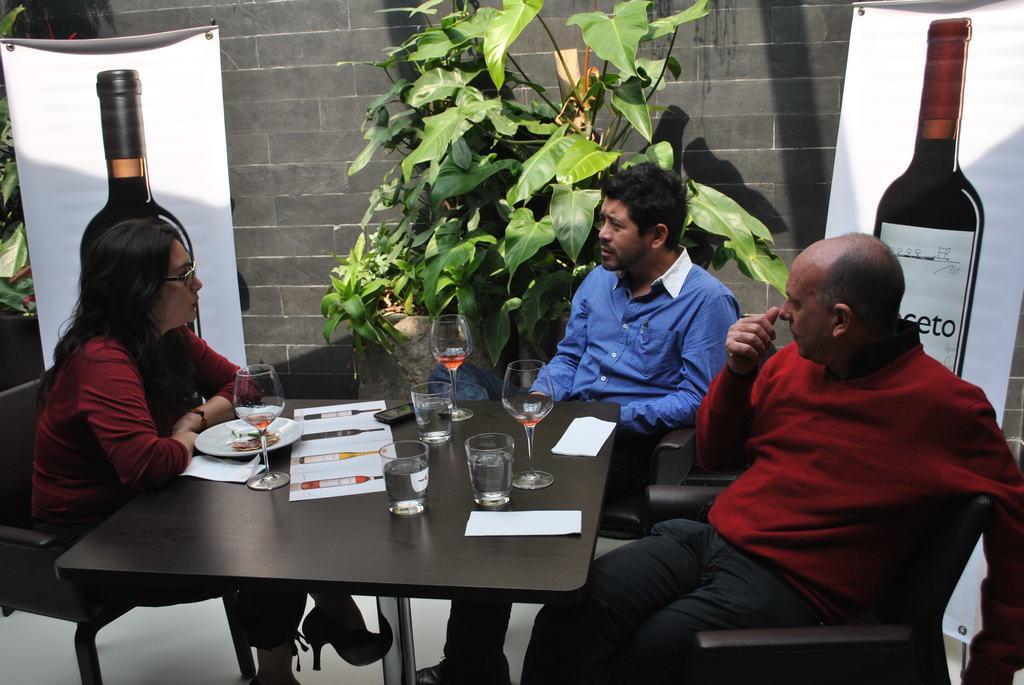Could you give a brief overview of what you see in this image? In this image there is a table which is in black color on which there are some glasses there are some peoples sitting on the chairs in the background there is a wall which is in black color and there are some leaves which is in green color and some posters on which a bottle is there. 